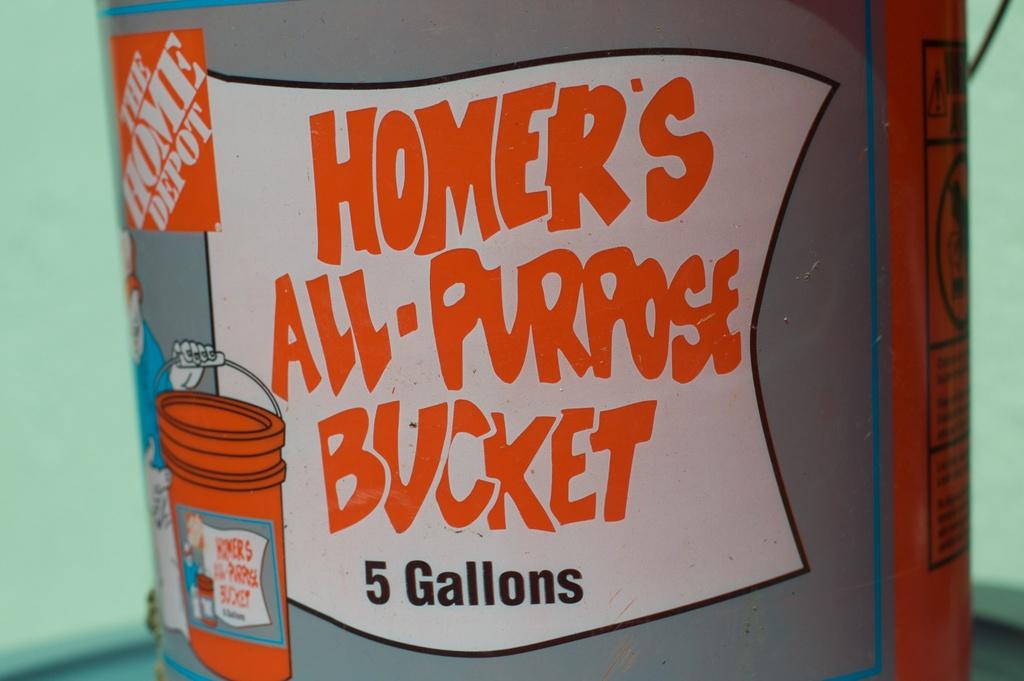How many gallons in this bucket?
Make the answer very short. 5. What type of bucket is this?
Give a very brief answer. All-purpose. 